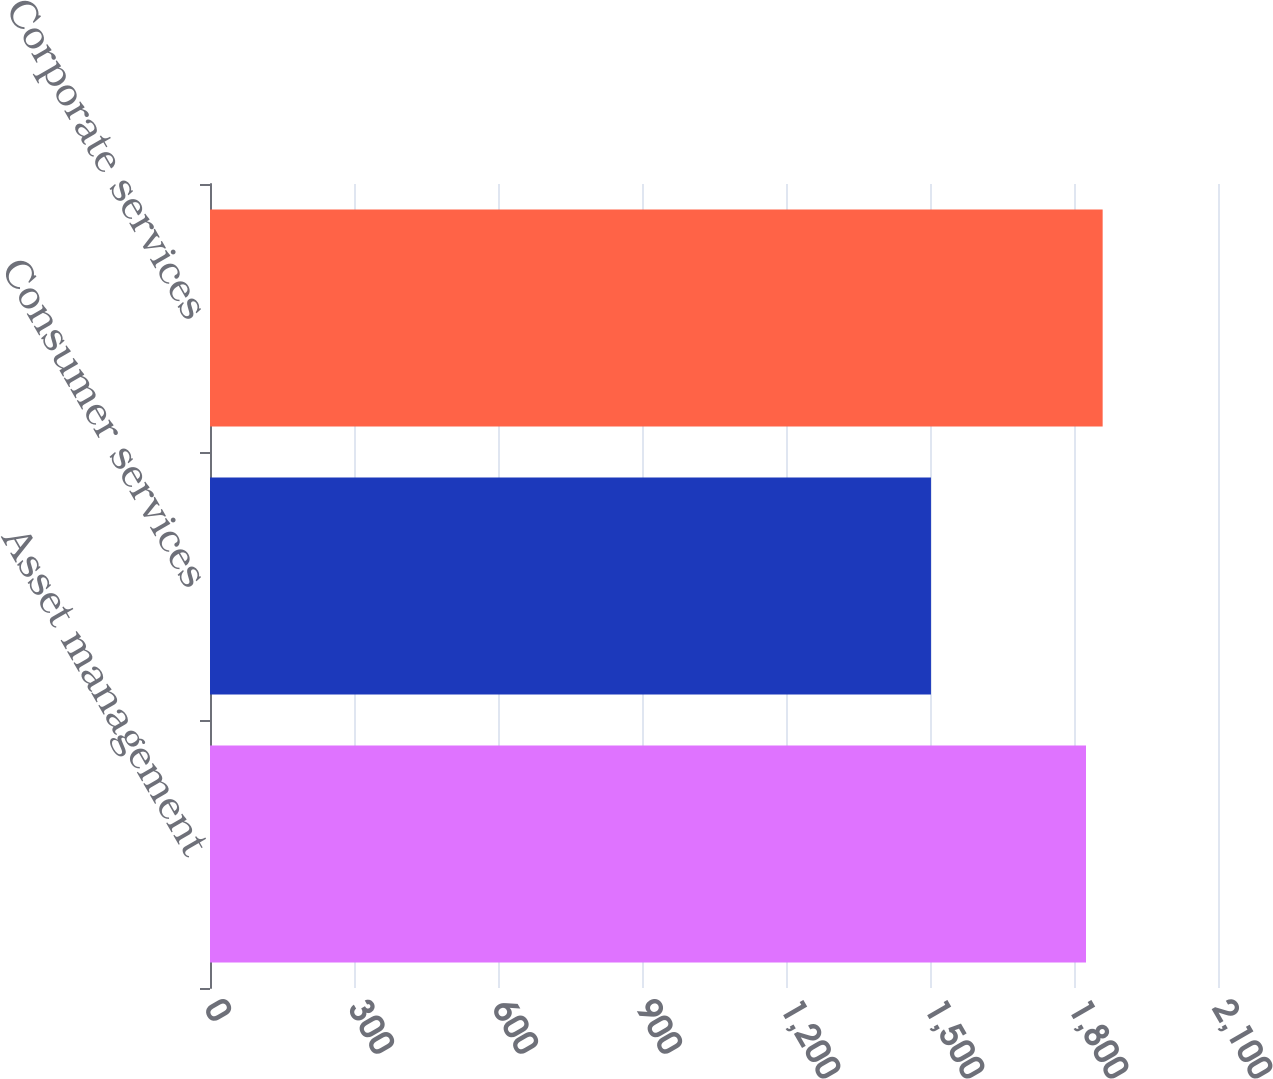Convert chart. <chart><loc_0><loc_0><loc_500><loc_500><bar_chart><fcel>Asset management<fcel>Consumer services<fcel>Corporate services<nl><fcel>1825<fcel>1502<fcel>1859.7<nl></chart> 